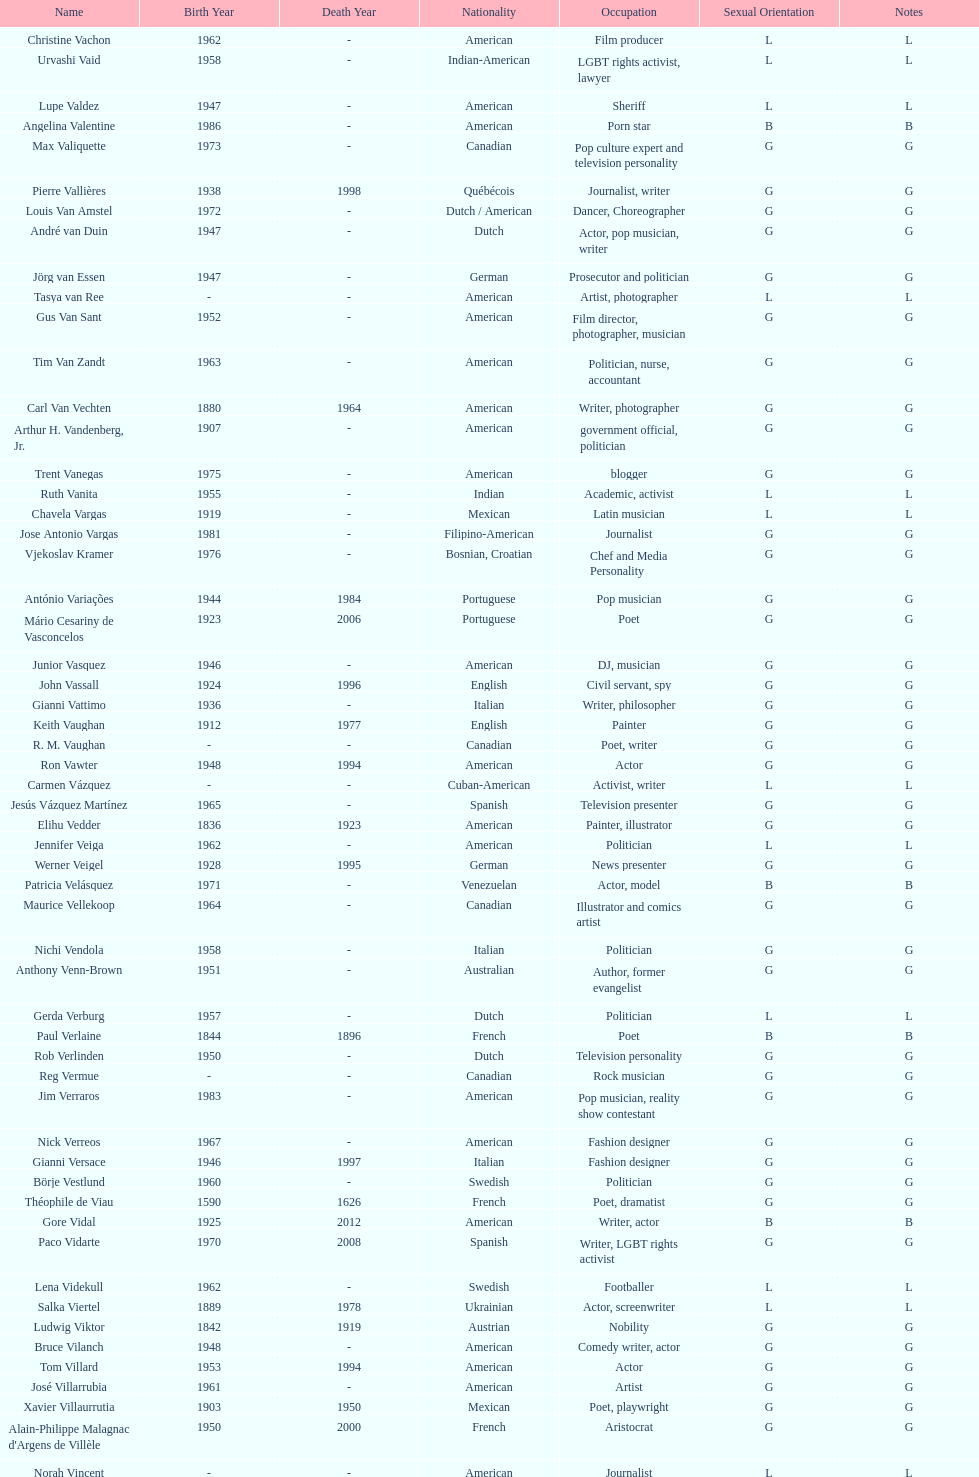Patricia velasquez and ron vawter both had what career? Actor. 